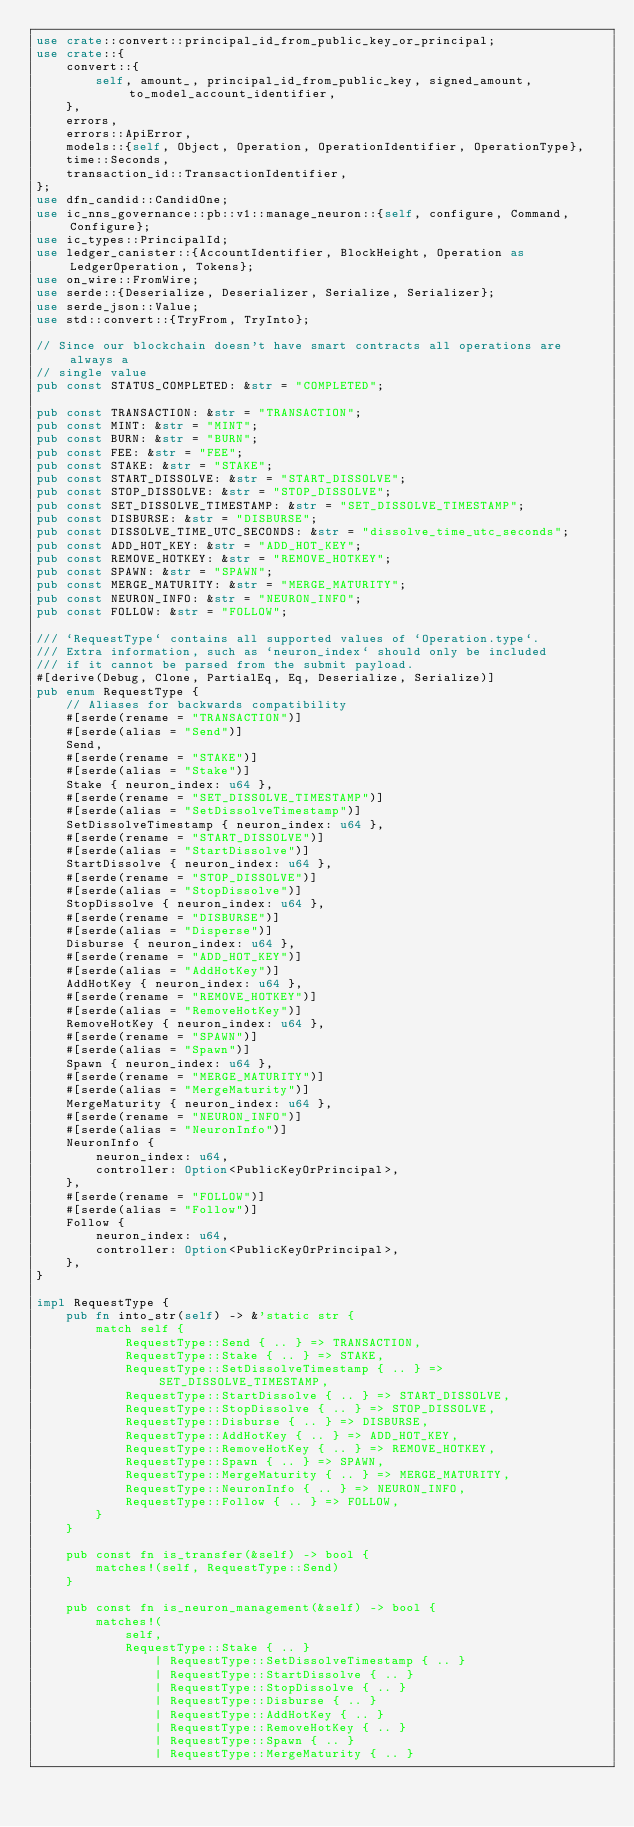<code> <loc_0><loc_0><loc_500><loc_500><_Rust_>use crate::convert::principal_id_from_public_key_or_principal;
use crate::{
    convert::{
        self, amount_, principal_id_from_public_key, signed_amount, to_model_account_identifier,
    },
    errors,
    errors::ApiError,
    models::{self, Object, Operation, OperationIdentifier, OperationType},
    time::Seconds,
    transaction_id::TransactionIdentifier,
};
use dfn_candid::CandidOne;
use ic_nns_governance::pb::v1::manage_neuron::{self, configure, Command, Configure};
use ic_types::PrincipalId;
use ledger_canister::{AccountIdentifier, BlockHeight, Operation as LedgerOperation, Tokens};
use on_wire::FromWire;
use serde::{Deserialize, Deserializer, Serialize, Serializer};
use serde_json::Value;
use std::convert::{TryFrom, TryInto};

// Since our blockchain doesn't have smart contracts all operations are always a
// single value
pub const STATUS_COMPLETED: &str = "COMPLETED";

pub const TRANSACTION: &str = "TRANSACTION";
pub const MINT: &str = "MINT";
pub const BURN: &str = "BURN";
pub const FEE: &str = "FEE";
pub const STAKE: &str = "STAKE";
pub const START_DISSOLVE: &str = "START_DISSOLVE";
pub const STOP_DISSOLVE: &str = "STOP_DISSOLVE";
pub const SET_DISSOLVE_TIMESTAMP: &str = "SET_DISSOLVE_TIMESTAMP";
pub const DISBURSE: &str = "DISBURSE";
pub const DISSOLVE_TIME_UTC_SECONDS: &str = "dissolve_time_utc_seconds";
pub const ADD_HOT_KEY: &str = "ADD_HOT_KEY";
pub const REMOVE_HOTKEY: &str = "REMOVE_HOTKEY";
pub const SPAWN: &str = "SPAWN";
pub const MERGE_MATURITY: &str = "MERGE_MATURITY";
pub const NEURON_INFO: &str = "NEURON_INFO";
pub const FOLLOW: &str = "FOLLOW";

/// `RequestType` contains all supported values of `Operation.type`.
/// Extra information, such as `neuron_index` should only be included
/// if it cannot be parsed from the submit payload.
#[derive(Debug, Clone, PartialEq, Eq, Deserialize, Serialize)]
pub enum RequestType {
    // Aliases for backwards compatibility
    #[serde(rename = "TRANSACTION")]
    #[serde(alias = "Send")]
    Send,
    #[serde(rename = "STAKE")]
    #[serde(alias = "Stake")]
    Stake { neuron_index: u64 },
    #[serde(rename = "SET_DISSOLVE_TIMESTAMP")]
    #[serde(alias = "SetDissolveTimestamp")]
    SetDissolveTimestamp { neuron_index: u64 },
    #[serde(rename = "START_DISSOLVE")]
    #[serde(alias = "StartDissolve")]
    StartDissolve { neuron_index: u64 },
    #[serde(rename = "STOP_DISSOLVE")]
    #[serde(alias = "StopDissolve")]
    StopDissolve { neuron_index: u64 },
    #[serde(rename = "DISBURSE")]
    #[serde(alias = "Disperse")]
    Disburse { neuron_index: u64 },
    #[serde(rename = "ADD_HOT_KEY")]
    #[serde(alias = "AddHotKey")]
    AddHotKey { neuron_index: u64 },
    #[serde(rename = "REMOVE_HOTKEY")]
    #[serde(alias = "RemoveHotKey")]
    RemoveHotKey { neuron_index: u64 },
    #[serde(rename = "SPAWN")]
    #[serde(alias = "Spawn")]
    Spawn { neuron_index: u64 },
    #[serde(rename = "MERGE_MATURITY")]
    #[serde(alias = "MergeMaturity")]
    MergeMaturity { neuron_index: u64 },
    #[serde(rename = "NEURON_INFO")]
    #[serde(alias = "NeuronInfo")]
    NeuronInfo {
        neuron_index: u64,
        controller: Option<PublicKeyOrPrincipal>,
    },
    #[serde(rename = "FOLLOW")]
    #[serde(alias = "Follow")]
    Follow {
        neuron_index: u64,
        controller: Option<PublicKeyOrPrincipal>,
    },
}

impl RequestType {
    pub fn into_str(self) -> &'static str {
        match self {
            RequestType::Send { .. } => TRANSACTION,
            RequestType::Stake { .. } => STAKE,
            RequestType::SetDissolveTimestamp { .. } => SET_DISSOLVE_TIMESTAMP,
            RequestType::StartDissolve { .. } => START_DISSOLVE,
            RequestType::StopDissolve { .. } => STOP_DISSOLVE,
            RequestType::Disburse { .. } => DISBURSE,
            RequestType::AddHotKey { .. } => ADD_HOT_KEY,
            RequestType::RemoveHotKey { .. } => REMOVE_HOTKEY,
            RequestType::Spawn { .. } => SPAWN,
            RequestType::MergeMaturity { .. } => MERGE_MATURITY,
            RequestType::NeuronInfo { .. } => NEURON_INFO,
            RequestType::Follow { .. } => FOLLOW,
        }
    }

    pub const fn is_transfer(&self) -> bool {
        matches!(self, RequestType::Send)
    }

    pub const fn is_neuron_management(&self) -> bool {
        matches!(
            self,
            RequestType::Stake { .. }
                | RequestType::SetDissolveTimestamp { .. }
                | RequestType::StartDissolve { .. }
                | RequestType::StopDissolve { .. }
                | RequestType::Disburse { .. }
                | RequestType::AddHotKey { .. }
                | RequestType::RemoveHotKey { .. }
                | RequestType::Spawn { .. }
                | RequestType::MergeMaturity { .. }</code> 